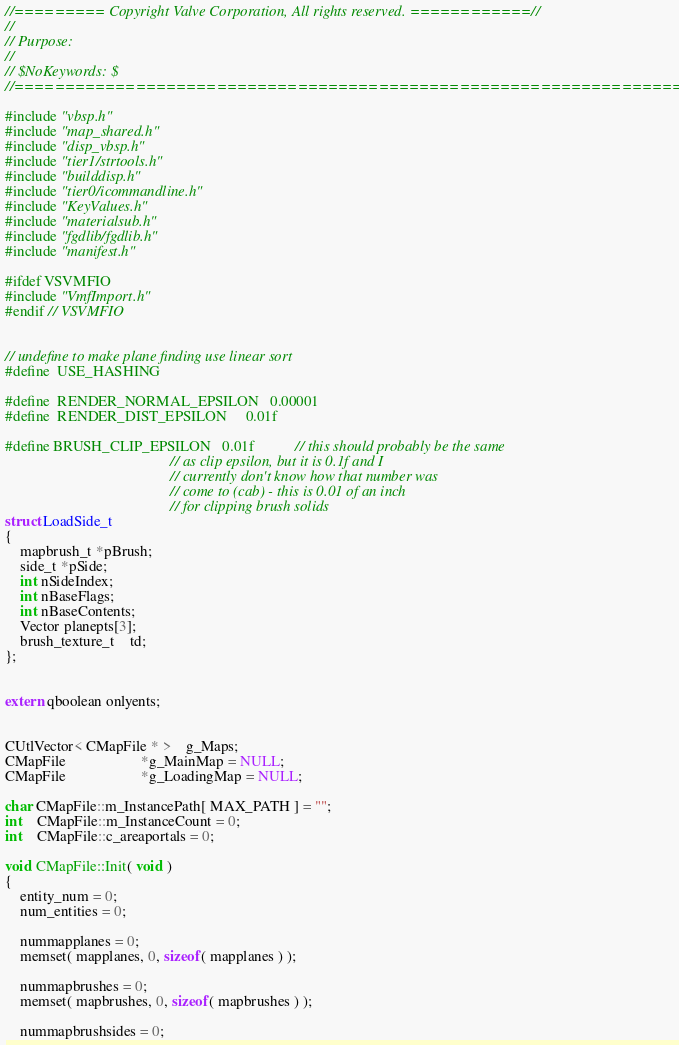<code> <loc_0><loc_0><loc_500><loc_500><_C++_>//========= Copyright Valve Corporation, All rights reserved. ============//
//
// Purpose: 
//
// $NoKeywords: $
//=============================================================================//

#include "vbsp.h"
#include "map_shared.h"
#include "disp_vbsp.h"
#include "tier1/strtools.h"
#include "builddisp.h"
#include "tier0/icommandline.h"
#include "KeyValues.h"
#include "materialsub.h"
#include "fgdlib/fgdlib.h"
#include "manifest.h"

#ifdef VSVMFIO
#include "VmfImport.h"
#endif // VSVMFIO


// undefine to make plane finding use linear sort
#define	USE_HASHING

#define	RENDER_NORMAL_EPSILON	0.00001
#define	RENDER_DIST_EPSILON	    0.01f

#define BRUSH_CLIP_EPSILON	0.01f			// this should probably be the same
                                            // as clip epsilon, but it is 0.1f and I
											// currently don't know how that number was 
											// come to (cab) - this is 0.01 of an inch
											// for clipping brush solids
struct LoadSide_t
{
	mapbrush_t *pBrush;
	side_t *pSide;
	int nSideIndex;
	int nBaseFlags;
	int nBaseContents;
	Vector planepts[3];
	brush_texture_t	td;
};


extern qboolean onlyents;


CUtlVector< CMapFile * >	g_Maps;
CMapFile					*g_MainMap = NULL;
CMapFile					*g_LoadingMap = NULL;

char CMapFile::m_InstancePath[ MAX_PATH ] = "";
int	CMapFile::m_InstanceCount = 0;
int	CMapFile::c_areaportals = 0;

void CMapFile::Init( void )
{
	entity_num = 0;
	num_entities = 0;

	nummapplanes = 0;
	memset( mapplanes, 0, sizeof( mapplanes ) );

	nummapbrushes = 0;
	memset( mapbrushes, 0, sizeof( mapbrushes ) );

	nummapbrushsides = 0;</code> 